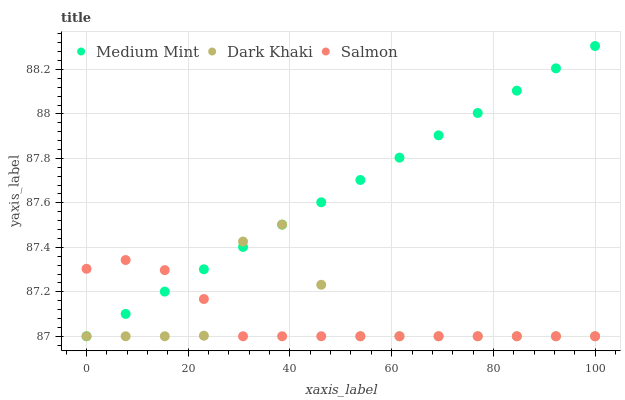Does Salmon have the minimum area under the curve?
Answer yes or no. Yes. Does Medium Mint have the maximum area under the curve?
Answer yes or no. Yes. Does Dark Khaki have the minimum area under the curve?
Answer yes or no. No. Does Dark Khaki have the maximum area under the curve?
Answer yes or no. No. Is Medium Mint the smoothest?
Answer yes or no. Yes. Is Dark Khaki the roughest?
Answer yes or no. Yes. Is Salmon the smoothest?
Answer yes or no. No. Is Salmon the roughest?
Answer yes or no. No. Does Medium Mint have the lowest value?
Answer yes or no. Yes. Does Medium Mint have the highest value?
Answer yes or no. Yes. Does Dark Khaki have the highest value?
Answer yes or no. No. Does Dark Khaki intersect Salmon?
Answer yes or no. Yes. Is Dark Khaki less than Salmon?
Answer yes or no. No. Is Dark Khaki greater than Salmon?
Answer yes or no. No. 